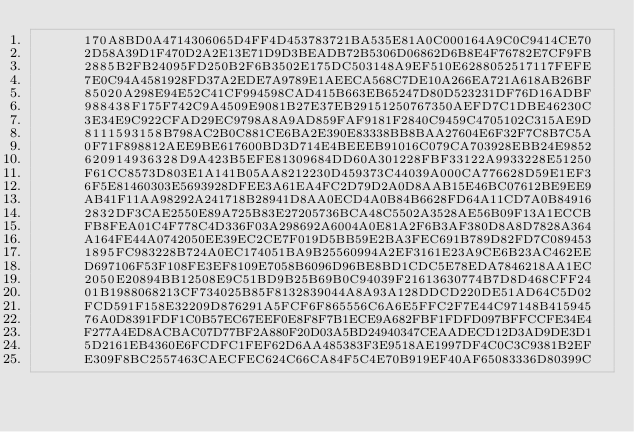Convert code to text. <code><loc_0><loc_0><loc_500><loc_500><_Pascal_>      170A8BD0A4714306065D4FF4D453783721BA535E81A0C000164A9C0C9414CE70
      2D58A39D1F470D2A2E13E71D9D3BEADB72B5306D06862D6B8E4F76782E7CF9FB
      2885B2FB24095FD250B2F6B3502E175DC503148A9EF510E6288052517117FEFE
      7E0C94A4581928FD37A2EDE7A9789E1AEECA568C7DE10A266EA721A618AB26BF
      85020A298E94E52C41CF994598CAD415B663EB65247D80D523231DF76D16ADBF
      988438F175F742C9A4509E9081B27E37EB29151250767350AEFD7C1DBE46230C
      3E34E9C922CFAD29EC9798A8A9AD859FAF9181F2840C9459C4705102C315AE9D
      8111593158B798AC2B0C881CE6BA2E390E83338BB8BAA27604E6F32F7C8B7C5A
      0F71F898812AEE9BE617600BD3D714E4BEEEB91016C079CA703928EBB24E9852
      620914936328D9A423B5EFE81309684DD60A301228FBF33122A9933228E51250
      F61CC8573D803E1A141B05AA8212230D459373C44039A000CA776628D59E1EF3
      6F5E81460303E5693928DFEE3A61EA4FC2D79D2A0D8AAB15E46BC07612BE9EE9
      AB41F11AA98292A241718B28941D8AA0ECD4A0B84B6628FD64A11CD7A0B84916
      2832DF3CAE2550E89A725B83E27205736BCA48C5502A3528AE56B09F13A1ECCB
      FB8FEA01C4F778C4D336F03A298692A6004A0E81A2F6B3AF380D8A8D7828A364
      A164FE44A0742050EE39EC2CE7F019D5BB59E2BA3FEC691B789D82FD7C089453
      1895FC983228B724A0EC174051BA9B25560994A2EF3161E23A9CE6B23AC462EE
      D697106F53F108FE3EF8109E7058B6096D96BE8BD1CDC5E78EDA7846218AA1EC
      2050E20894BB12508E9C51BD9B25B69B0C94039F21613630774B7D8D468CFF24
      01B1988068213CF734025B85F8132839044A8A93A128DDCD220DE51AD64C5D02
      FCD591F158E32209D876291A5FCF6F865556C6A6E5FFC2F7E44C97148B415945
      76A0D8391FDF1C0B57EC67EEF0E8F8F7B1ECE9A682FBF1FDFD097BFFCCFE34E4
      F277A4ED8ACBAC07D77BF2A880F20D03A5BD24940347CEAADECD12D3AD9DE3D1
      5D2161EB4360E6FCDFC1FEF62D6AA485383F3E9518AE1997DF4C0C3C9381B2EF
      E309F8BC2557463CAECFEC624C66CA84F5C4E70B919EF40AF65083336D80399C</code> 